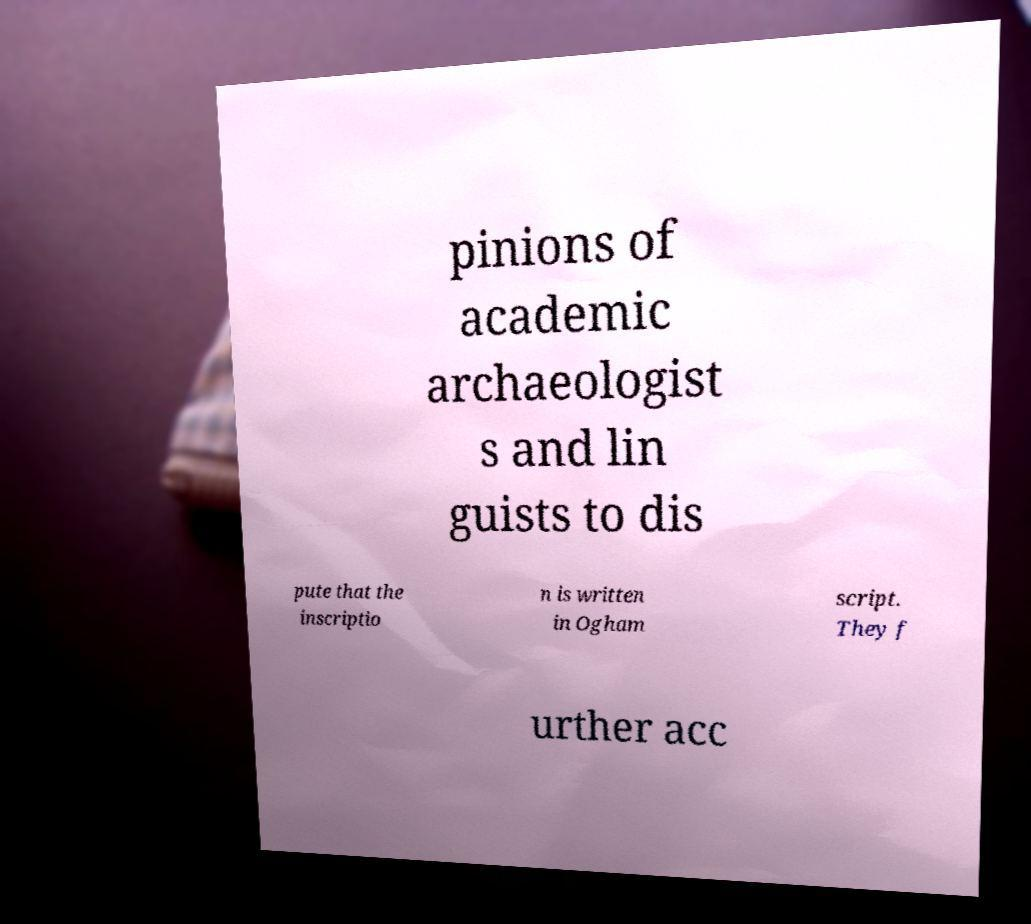For documentation purposes, I need the text within this image transcribed. Could you provide that? pinions of academic archaeologist s and lin guists to dis pute that the inscriptio n is written in Ogham script. They f urther acc 